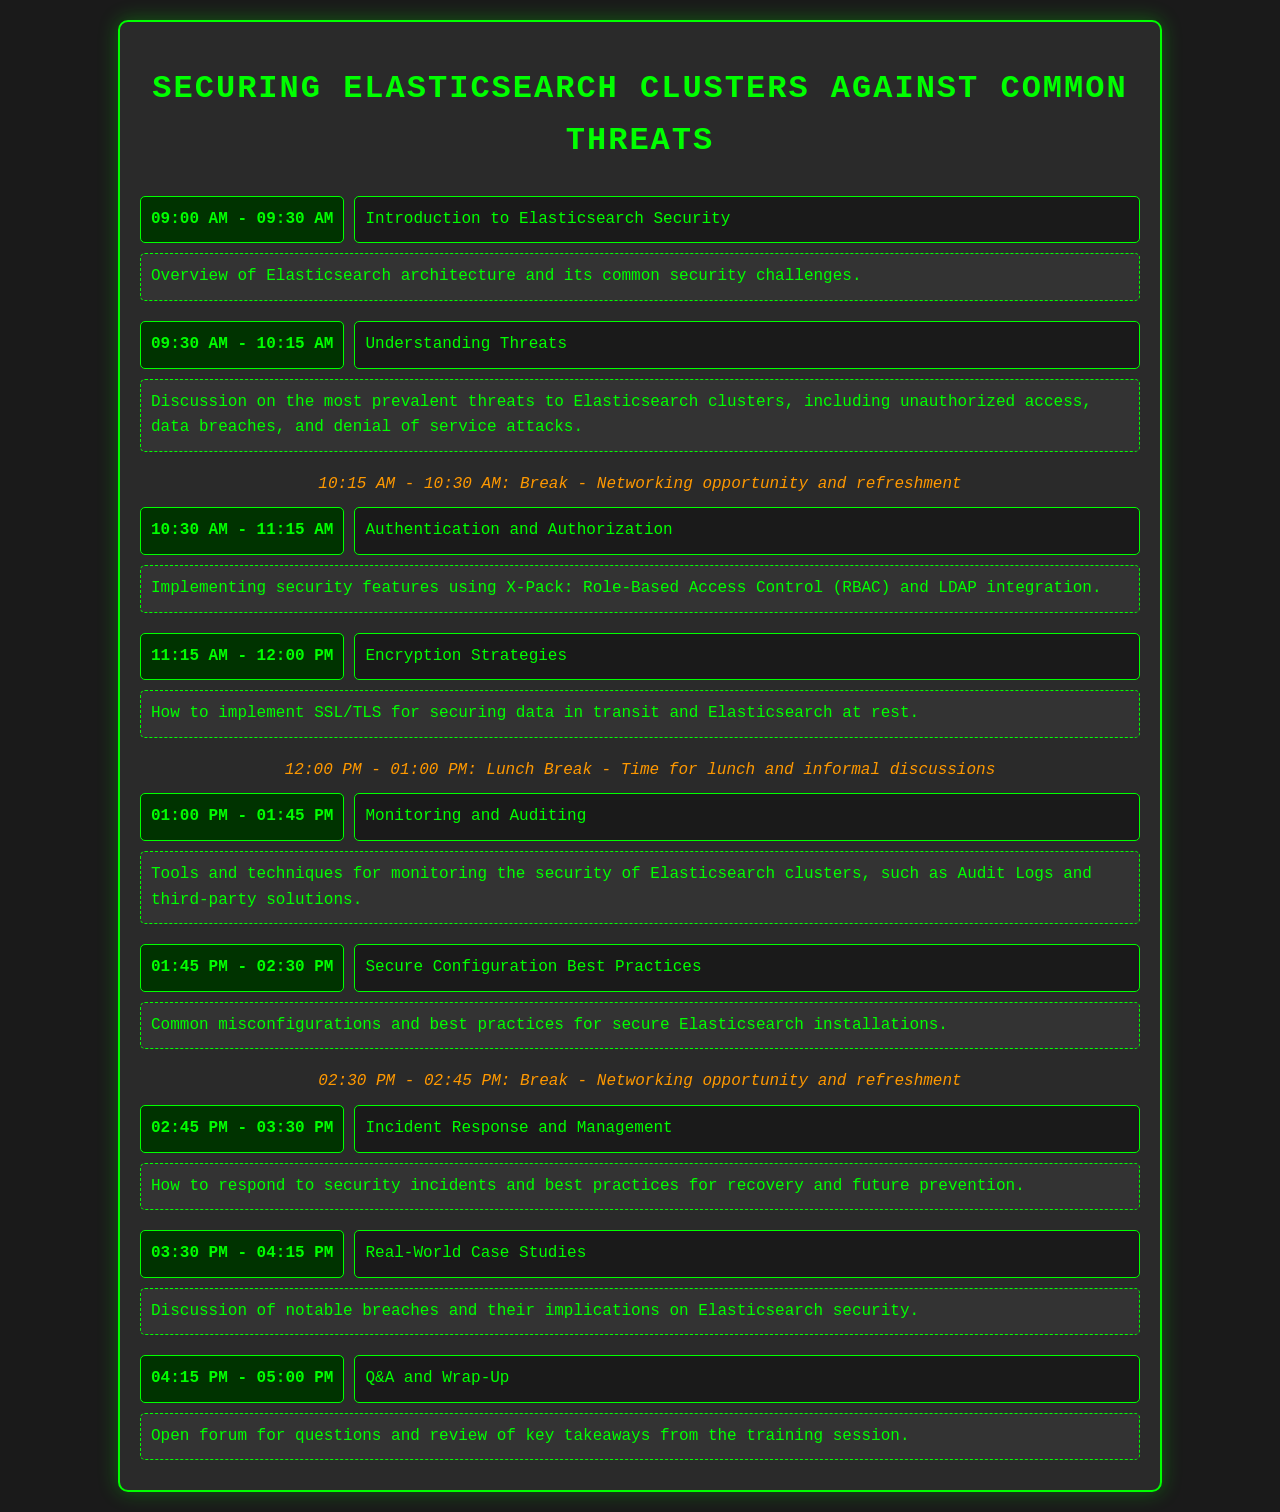What time does the training session start? The training session starts at the time indicated in the schedule, which is set at 09:00 AM.
Answer: 09:00 AM What is the topic of the third session? The topic of the third session is listed in the schedule immediately after the second session and is titled "Authentication and Authorization."
Answer: Authentication and Authorization How long is the break after the second session? The break after the second session is specified in the schedule, indicating its duration of 15 minutes.
Answer: 15 minutes What is discussed during the session on "Incident Response and Management"? The content for this session provides information about responding to security incidents and best practices, as indicated in the schedule.
Answer: Respond to security incidents and best practices Which session is dedicated to real-world examples? The session that discusses notable breaches and their implications is highlighted in the schedule as "Real-World Case Studies."
Answer: Real-World Case Studies What kind of refreshment opportunity is provided before the last session? The schedule mentions a break before the last session, indicating that it serves as a networking opportunity and refreshment.
Answer: Networking opportunity and refreshment 